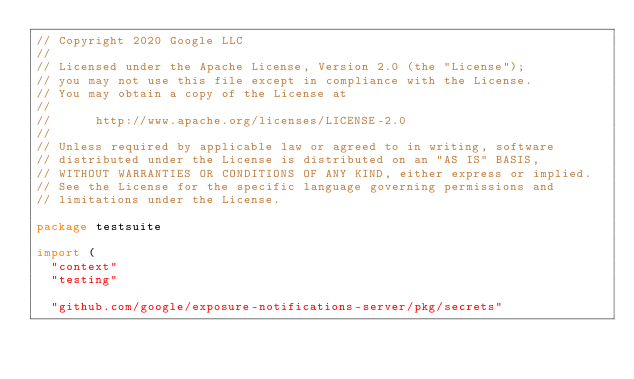Convert code to text. <code><loc_0><loc_0><loc_500><loc_500><_Go_>// Copyright 2020 Google LLC
//
// Licensed under the Apache License, Version 2.0 (the "License");
// you may not use this file except in compliance with the License.
// You may obtain a copy of the License at
//
//      http://www.apache.org/licenses/LICENSE-2.0
//
// Unless required by applicable law or agreed to in writing, software
// distributed under the License is distributed on an "AS IS" BASIS,
// WITHOUT WARRANTIES OR CONDITIONS OF ANY KIND, either express or implied.
// See the License for the specific language governing permissions and
// limitations under the License.

package testsuite

import (
	"context"
	"testing"

	"github.com/google/exposure-notifications-server/pkg/secrets"</code> 